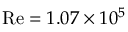Convert formula to latex. <formula><loc_0><loc_0><loc_500><loc_500>R e = 1 . 0 7 \times 1 0 ^ { 5 }</formula> 